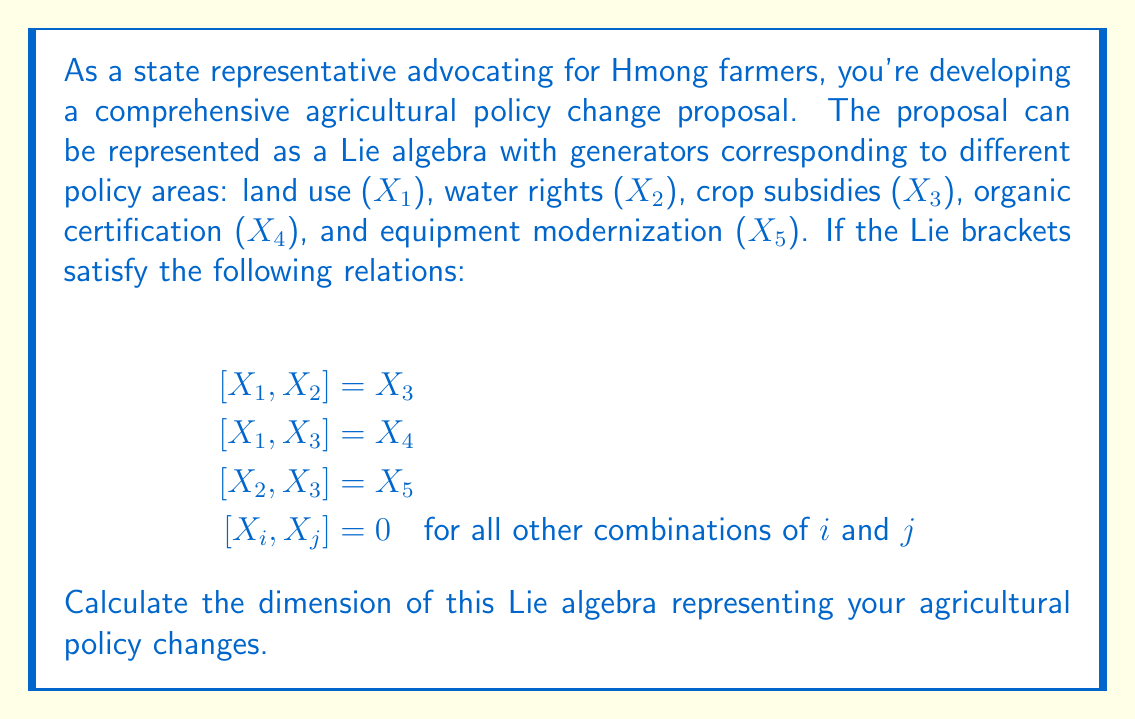Provide a solution to this math problem. To determine the dimension of a Lie algebra, we need to find the number of linearly independent generators. In this case, we'll examine the given generators and their relationships:

1) We start with 5 generators: $X_1$, $X_2$, $X_3$, $X_4$, and $X_5$.

2) Let's check if any of these generators can be expressed as a combination of others:

   - $X_3$ can be obtained from $[X_1, X_2]$, but this doesn't reduce the dimension as $X_3$ is needed to generate $X_4$ and $X_5$.
   - $X_4$ is generated by $[X_1, X_3]$, but it can't be expressed as a linear combination of $X_1$, $X_2$, and $X_3$.
   - $X_5$ is generated by $[X_2, X_3]$, but it can't be expressed as a linear combination of $X_1$, $X_2$, $X_3$, and $X_4$.

3) All other Lie brackets are zero, which means no other combinations of generators produce new elements.

4) Therefore, all five generators $X_1$, $X_2$, $X_3$, $X_4$, and $X_5$ are necessary and linearly independent.

The dimension of a Lie algebra is equal to the number of linearly independent generators. In this case, we have 5 linearly independent generators, so the dimension of the Lie algebra is 5.
Answer: The dimension of the Lie algebra representing the agricultural policy changes is 5. 